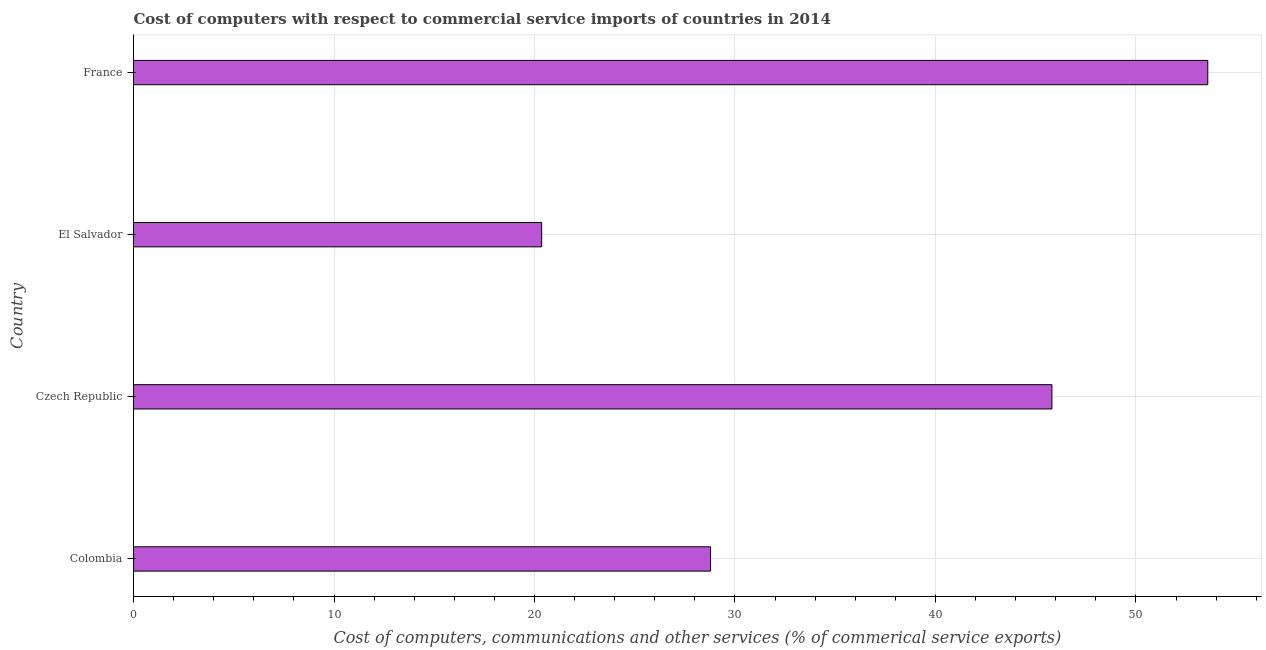Does the graph contain any zero values?
Your response must be concise. No. Does the graph contain grids?
Your response must be concise. Yes. What is the title of the graph?
Offer a terse response. Cost of computers with respect to commercial service imports of countries in 2014. What is the label or title of the X-axis?
Your answer should be very brief. Cost of computers, communications and other services (% of commerical service exports). What is the cost of communications in El Salvador?
Offer a terse response. 20.36. Across all countries, what is the maximum cost of communications?
Make the answer very short. 53.58. Across all countries, what is the minimum  computer and other services?
Provide a succinct answer. 20.36. In which country was the  computer and other services minimum?
Make the answer very short. El Salvador. What is the sum of the  computer and other services?
Your response must be concise. 148.53. What is the difference between the cost of communications in El Salvador and France?
Keep it short and to the point. -33.23. What is the average cost of communications per country?
Your answer should be very brief. 37.13. What is the median cost of communications?
Provide a short and direct response. 37.3. In how many countries, is the  computer and other services greater than 44 %?
Make the answer very short. 2. What is the ratio of the  computer and other services in Czech Republic to that in El Salvador?
Provide a succinct answer. 2.25. Is the difference between the cost of communications in Czech Republic and El Salvador greater than the difference between any two countries?
Ensure brevity in your answer.  No. What is the difference between the highest and the second highest  computer and other services?
Make the answer very short. 7.77. Is the sum of the cost of communications in Colombia and France greater than the maximum cost of communications across all countries?
Keep it short and to the point. Yes. What is the difference between the highest and the lowest cost of communications?
Make the answer very short. 33.22. In how many countries, is the  computer and other services greater than the average  computer and other services taken over all countries?
Ensure brevity in your answer.  2. How many bars are there?
Offer a terse response. 4. Are all the bars in the graph horizontal?
Give a very brief answer. Yes. How many countries are there in the graph?
Your response must be concise. 4. What is the difference between two consecutive major ticks on the X-axis?
Provide a succinct answer. 10. What is the Cost of computers, communications and other services (% of commerical service exports) in Colombia?
Keep it short and to the point. 28.78. What is the Cost of computers, communications and other services (% of commerical service exports) in Czech Republic?
Keep it short and to the point. 45.81. What is the Cost of computers, communications and other services (% of commerical service exports) of El Salvador?
Make the answer very short. 20.36. What is the Cost of computers, communications and other services (% of commerical service exports) of France?
Offer a terse response. 53.58. What is the difference between the Cost of computers, communications and other services (% of commerical service exports) in Colombia and Czech Republic?
Provide a short and direct response. -17.03. What is the difference between the Cost of computers, communications and other services (% of commerical service exports) in Colombia and El Salvador?
Your answer should be compact. 8.42. What is the difference between the Cost of computers, communications and other services (% of commerical service exports) in Colombia and France?
Make the answer very short. -24.8. What is the difference between the Cost of computers, communications and other services (% of commerical service exports) in Czech Republic and El Salvador?
Offer a terse response. 25.45. What is the difference between the Cost of computers, communications and other services (% of commerical service exports) in Czech Republic and France?
Keep it short and to the point. -7.77. What is the difference between the Cost of computers, communications and other services (% of commerical service exports) in El Salvador and France?
Offer a terse response. -33.22. What is the ratio of the Cost of computers, communications and other services (% of commerical service exports) in Colombia to that in Czech Republic?
Offer a terse response. 0.63. What is the ratio of the Cost of computers, communications and other services (% of commerical service exports) in Colombia to that in El Salvador?
Your answer should be compact. 1.41. What is the ratio of the Cost of computers, communications and other services (% of commerical service exports) in Colombia to that in France?
Your response must be concise. 0.54. What is the ratio of the Cost of computers, communications and other services (% of commerical service exports) in Czech Republic to that in El Salvador?
Your answer should be compact. 2.25. What is the ratio of the Cost of computers, communications and other services (% of commerical service exports) in Czech Republic to that in France?
Provide a short and direct response. 0.85. What is the ratio of the Cost of computers, communications and other services (% of commerical service exports) in El Salvador to that in France?
Keep it short and to the point. 0.38. 